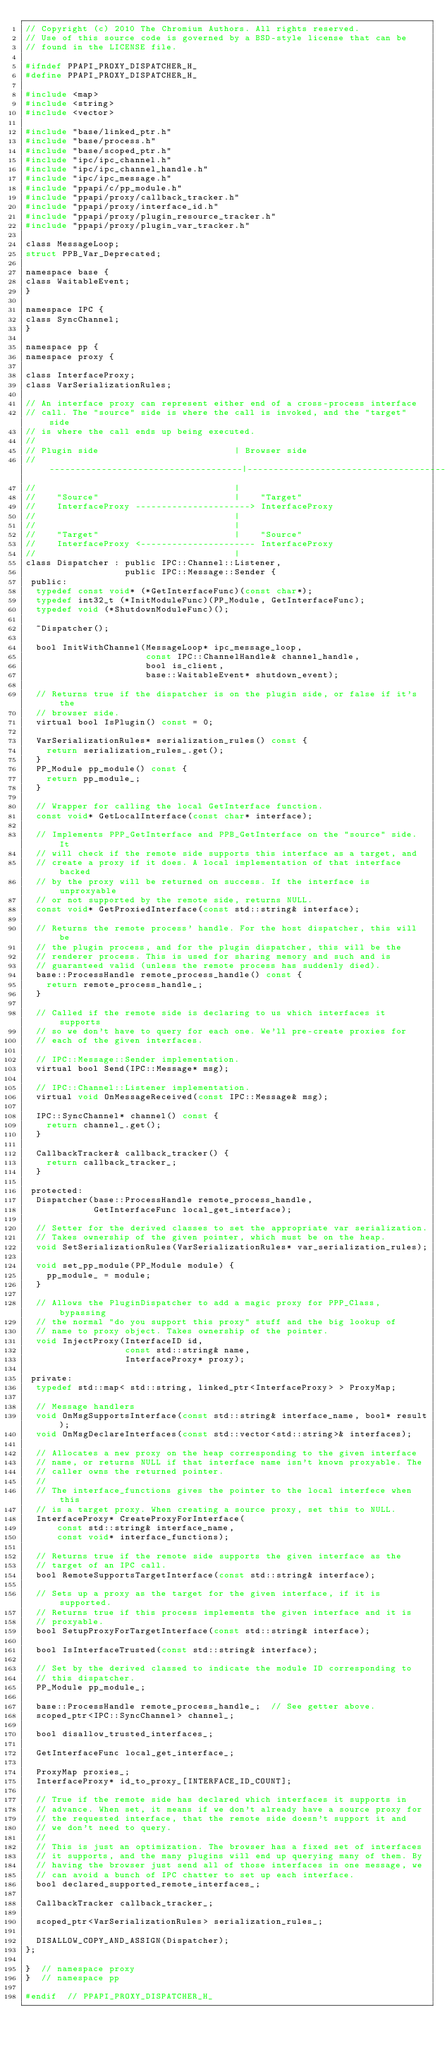<code> <loc_0><loc_0><loc_500><loc_500><_C_>// Copyright (c) 2010 The Chromium Authors. All rights reserved.
// Use of this source code is governed by a BSD-style license that can be
// found in the LICENSE file.

#ifndef PPAPI_PROXY_DISPATCHER_H_
#define PPAPI_PROXY_DISPATCHER_H_

#include <map>
#include <string>
#include <vector>

#include "base/linked_ptr.h"
#include "base/process.h"
#include "base/scoped_ptr.h"
#include "ipc/ipc_channel.h"
#include "ipc/ipc_channel_handle.h"
#include "ipc/ipc_message.h"
#include "ppapi/c/pp_module.h"
#include "ppapi/proxy/callback_tracker.h"
#include "ppapi/proxy/interface_id.h"
#include "ppapi/proxy/plugin_resource_tracker.h"
#include "ppapi/proxy/plugin_var_tracker.h"

class MessageLoop;
struct PPB_Var_Deprecated;

namespace base {
class WaitableEvent;
}

namespace IPC {
class SyncChannel;
}

namespace pp {
namespace proxy {

class InterfaceProxy;
class VarSerializationRules;

// An interface proxy can represent either end of a cross-process interface
// call. The "source" side is where the call is invoked, and the "target" side
// is where the call ends up being executed.
//
// Plugin side                          | Browser side
// -------------------------------------|--------------------------------------
//                                      |
//    "Source"                          |    "Target"
//    InterfaceProxy ----------------------> InterfaceProxy
//                                      |
//                                      |
//    "Target"                          |    "Source"
//    InterfaceProxy <---------------------- InterfaceProxy
//                                      |
class Dispatcher : public IPC::Channel::Listener,
                   public IPC::Message::Sender {
 public:
  typedef const void* (*GetInterfaceFunc)(const char*);
  typedef int32_t (*InitModuleFunc)(PP_Module, GetInterfaceFunc);
  typedef void (*ShutdownModuleFunc)();

  ~Dispatcher();

  bool InitWithChannel(MessageLoop* ipc_message_loop,
                       const IPC::ChannelHandle& channel_handle,
                       bool is_client,
                       base::WaitableEvent* shutdown_event);

  // Returns true if the dispatcher is on the plugin side, or false if it's the
  // browser side.
  virtual bool IsPlugin() const = 0;

  VarSerializationRules* serialization_rules() const {
    return serialization_rules_.get();
  }
  PP_Module pp_module() const {
    return pp_module_;
  }

  // Wrapper for calling the local GetInterface function.
  const void* GetLocalInterface(const char* interface);

  // Implements PPP_GetInterface and PPB_GetInterface on the "source" side. It
  // will check if the remote side supports this interface as a target, and
  // create a proxy if it does. A local implementation of that interface backed
  // by the proxy will be returned on success. If the interface is unproxyable
  // or not supported by the remote side, returns NULL.
  const void* GetProxiedInterface(const std::string& interface);

  // Returns the remote process' handle. For the host dispatcher, this will be
  // the plugin process, and for the plugin dispatcher, this will be the
  // renderer process. This is used for sharing memory and such and is
  // guaranteed valid (unless the remote process has suddenly died).
  base::ProcessHandle remote_process_handle() const {
    return remote_process_handle_;
  }

  // Called if the remote side is declaring to us which interfaces it supports
  // so we don't have to query for each one. We'll pre-create proxies for
  // each of the given interfaces.

  // IPC::Message::Sender implementation.
  virtual bool Send(IPC::Message* msg);

  // IPC::Channel::Listener implementation.
  virtual void OnMessageReceived(const IPC::Message& msg);

  IPC::SyncChannel* channel() const {
    return channel_.get();
  }

  CallbackTracker& callback_tracker() {
    return callback_tracker_;
  }

 protected:
  Dispatcher(base::ProcessHandle remote_process_handle,
             GetInterfaceFunc local_get_interface);

  // Setter for the derived classes to set the appropriate var serialization.
  // Takes ownership of the given pointer, which must be on the heap.
  void SetSerializationRules(VarSerializationRules* var_serialization_rules);

  void set_pp_module(PP_Module module) {
    pp_module_ = module;
  }

  // Allows the PluginDispatcher to add a magic proxy for PPP_Class, bypassing
  // the normal "do you support this proxy" stuff and the big lookup of
  // name to proxy object. Takes ownership of the pointer.
  void InjectProxy(InterfaceID id,
                   const std::string& name,
                   InterfaceProxy* proxy);

 private:
  typedef std::map< std::string, linked_ptr<InterfaceProxy> > ProxyMap;

  // Message handlers
  void OnMsgSupportsInterface(const std::string& interface_name, bool* result);
  void OnMsgDeclareInterfaces(const std::vector<std::string>& interfaces);

  // Allocates a new proxy on the heap corresponding to the given interface
  // name, or returns NULL if that interface name isn't known proxyable. The
  // caller owns the returned pointer.
  //
  // The interface_functions gives the pointer to the local interfece when this
  // is a target proxy. When creating a source proxy, set this to NULL.
  InterfaceProxy* CreateProxyForInterface(
      const std::string& interface_name,
      const void* interface_functions);

  // Returns true if the remote side supports the given interface as the
  // target of an IPC call.
  bool RemoteSupportsTargetInterface(const std::string& interface);

  // Sets up a proxy as the target for the given interface, if it is supported.
  // Returns true if this process implements the given interface and it is
  // proxyable.
  bool SetupProxyForTargetInterface(const std::string& interface);

  bool IsInterfaceTrusted(const std::string& interface);

  // Set by the derived classed to indicate the module ID corresponding to
  // this dispatcher.
  PP_Module pp_module_;

  base::ProcessHandle remote_process_handle_;  // See getter above.
  scoped_ptr<IPC::SyncChannel> channel_;

  bool disallow_trusted_interfaces_;

  GetInterfaceFunc local_get_interface_;

  ProxyMap proxies_;
  InterfaceProxy* id_to_proxy_[INTERFACE_ID_COUNT];

  // True if the remote side has declared which interfaces it supports in
  // advance. When set, it means if we don't already have a source proxy for
  // the requested interface, that the remote side doesn't support it and
  // we don't need to query.
  //
  // This is just an optimization. The browser has a fixed set of interfaces
  // it supports, and the many plugins will end up querying many of them. By
  // having the browser just send all of those interfaces in one message, we
  // can avoid a bunch of IPC chatter to set up each interface.
  bool declared_supported_remote_interfaces_;

  CallbackTracker callback_tracker_;

  scoped_ptr<VarSerializationRules> serialization_rules_;

  DISALLOW_COPY_AND_ASSIGN(Dispatcher);
};

}  // namespace proxy
}  // namespace pp

#endif  // PPAPI_PROXY_DISPATCHER_H_
</code> 